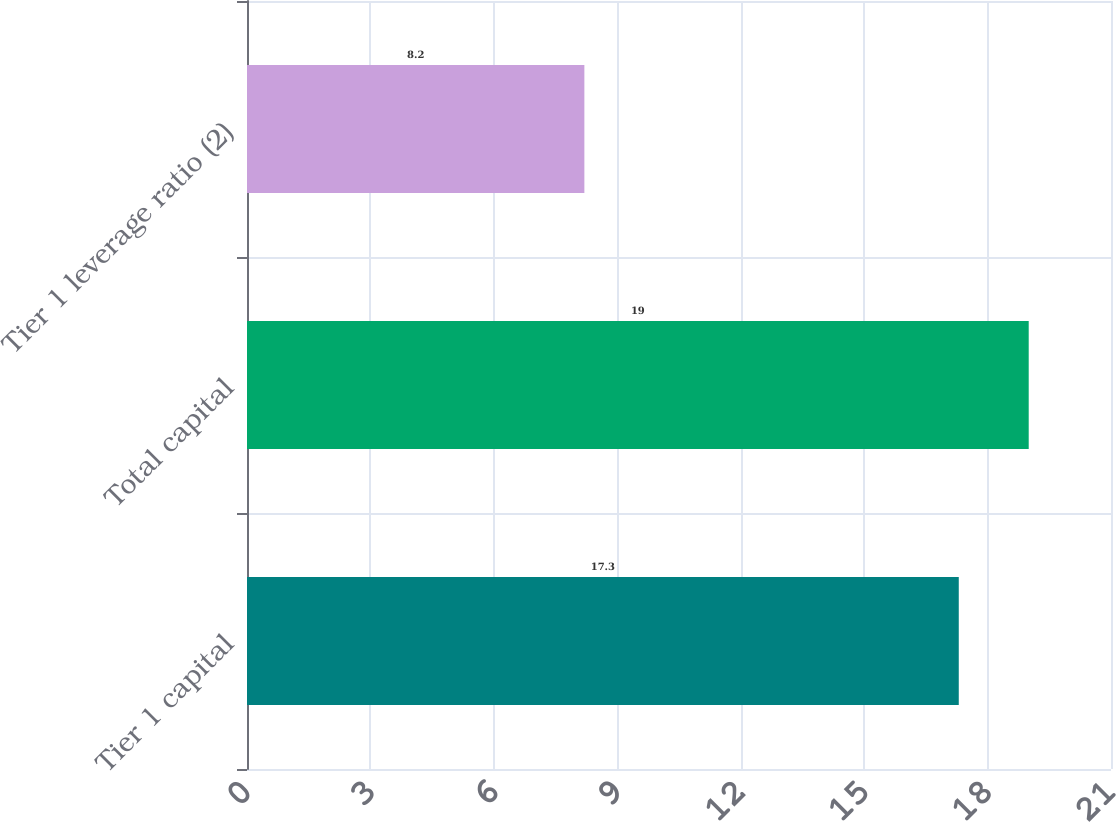Convert chart. <chart><loc_0><loc_0><loc_500><loc_500><bar_chart><fcel>Tier 1 capital<fcel>Total capital<fcel>Tier 1 leverage ratio (2)<nl><fcel>17.3<fcel>19<fcel>8.2<nl></chart> 